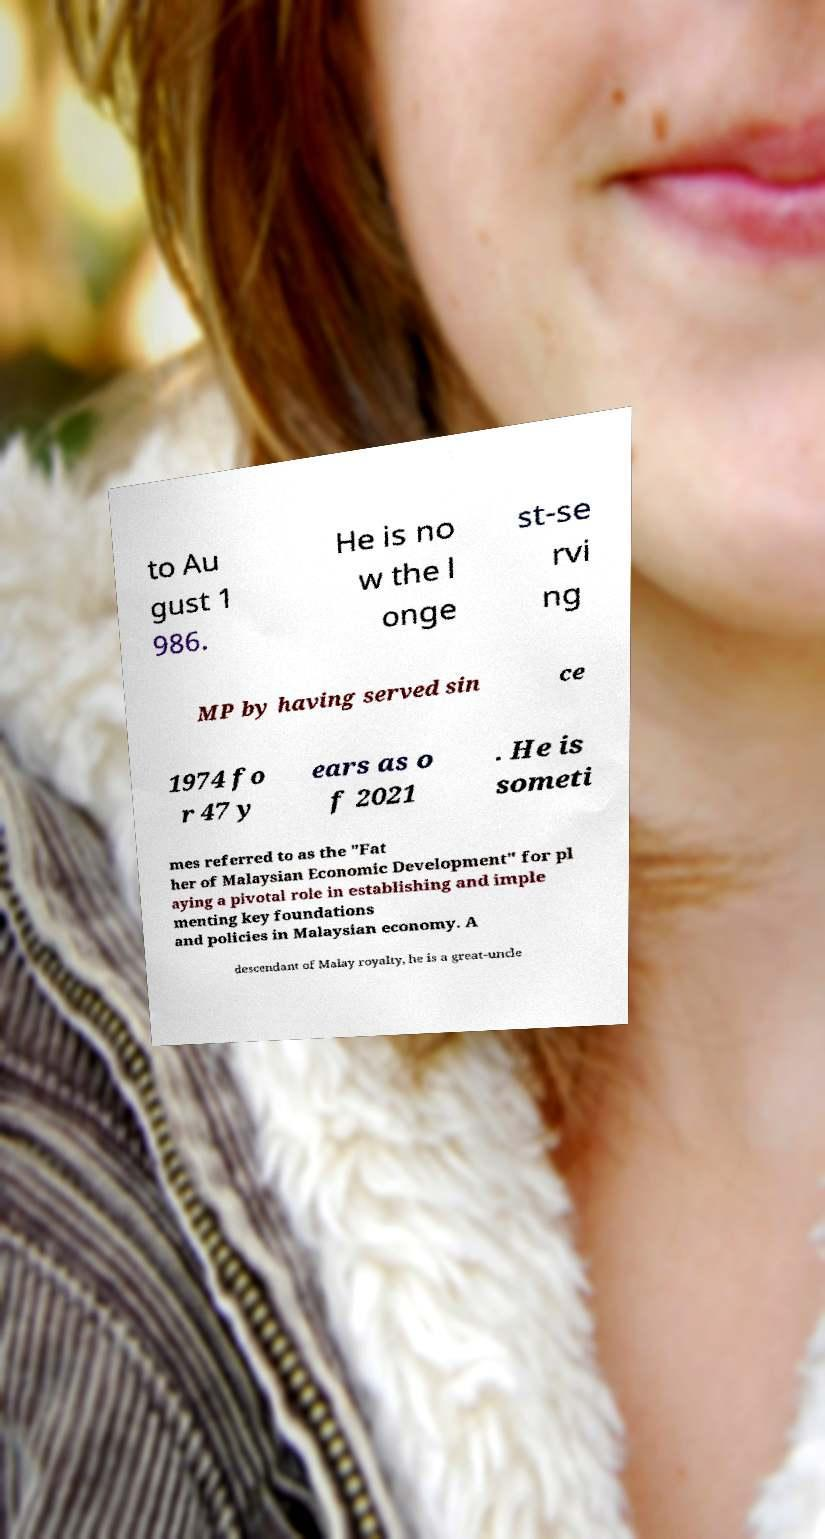I need the written content from this picture converted into text. Can you do that? to Au gust 1 986. He is no w the l onge st-se rvi ng MP by having served sin ce 1974 fo r 47 y ears as o f 2021 . He is someti mes referred to as the "Fat her of Malaysian Economic Development" for pl aying a pivotal role in establishing and imple menting key foundations and policies in Malaysian economy. A descendant of Malay royalty, he is a great-uncle 